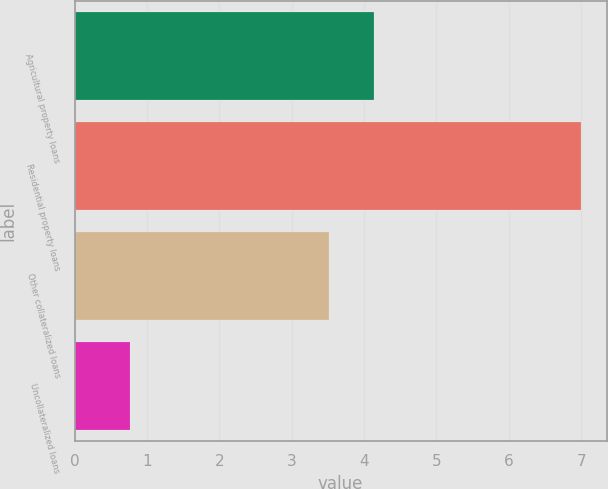Convert chart to OTSL. <chart><loc_0><loc_0><loc_500><loc_500><bar_chart><fcel>Agricultural property loans<fcel>Residential property loans<fcel>Other collateralized loans<fcel>Uncollateralized loans<nl><fcel>4.14<fcel>7<fcel>3.52<fcel>0.76<nl></chart> 